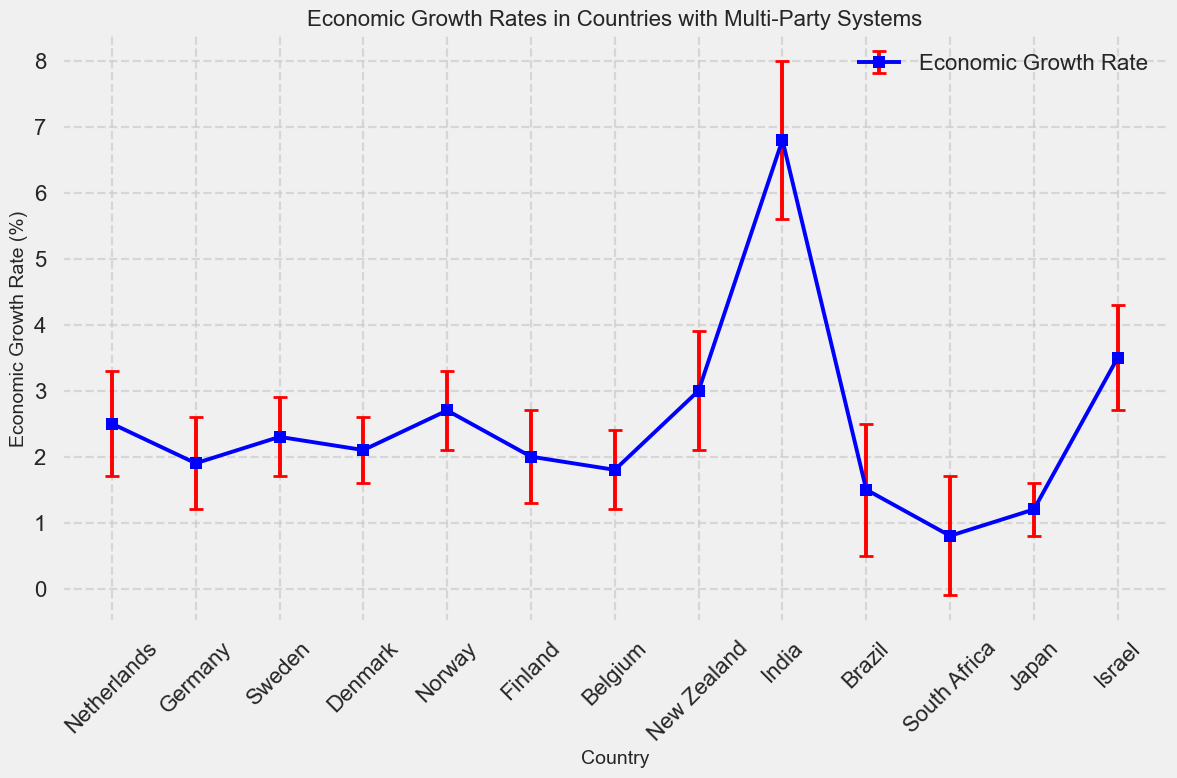Which country has the highest economic growth rate? The figure shows the economic growth rates for different countries. By looking at the heights of the markers, New Zealand has the highest growth rate.
Answer: New Zealand What is the economic growth rate of Germany? The economic growth rate of Germany can be directly read from the figure, represented by the marker for Germany.
Answer: 1.9% Which country has the largest standard deviation in its economic growth rate? The country with the largest standard deviation will have the longest error bar. India has the longest error bar in the figure.
Answer: India Compare the economic growth rates of Sweden and Denmark. Which one is higher? By comparing the heights of the markers for Sweden and Denmark, Sweden has a slightly higher economic growth rate than Denmark.
Answer: Sweden What is the average economic growth rate of the European countries listed (Netherlands, Germany, Sweden, Denmark, Norway, Finland, Belgium)? To find the average, sum the economic growth rates of these European countries and divide by the number of countries: (2.5 + 1.9 + 2.3 + 2.1 + 2.7 + 2.0 + 1.8) / 7 = 2.1857.
Answer: 2.19% Calculate the difference in economic growth rates between India and Brazil. The economic growth rates for India and Brazil are 6.8% and 1.5%, respectively. The difference is 6.8 - 1.5 = 5.3%.
Answer: 5.3% Which country has an economic growth rate closest to the median growth rate among the listed countries? To find the median, order the economic growth rates: 0.8, 1.2, 1.5, 1.8, 1.9, 2.0, 2.1, 2.3, 2.5, 2.7, 3.0, 3.5, 6.8. The median value is 2.1%. Denmark’s growth rate is 2.1%, which is the closest to the median.
Answer: Denmark Which countries have an economic growth rate above 2.0% and have standard deviations smaller than 0.7? Identify countries that meet both criteria: economic growth rate > 2.0% and standard deviation < 0.7. The relevant countries are Sweden, Denmark, and Norway.
Answer: Sweden, Denmark, Norway What is the average standard deviation of the economic growth rates for all countries listed? Sum the standard deviations and divide by the number of countries: (0.8 + 0.7 + 0.6 + 0.5 + 0.6 + 0.7 + 0.6 + 0.9 + 1.2 + 1.0 + 0.9 + 0.4 + 0.8) / 13 = 0.7231.
Answer: 0.72 